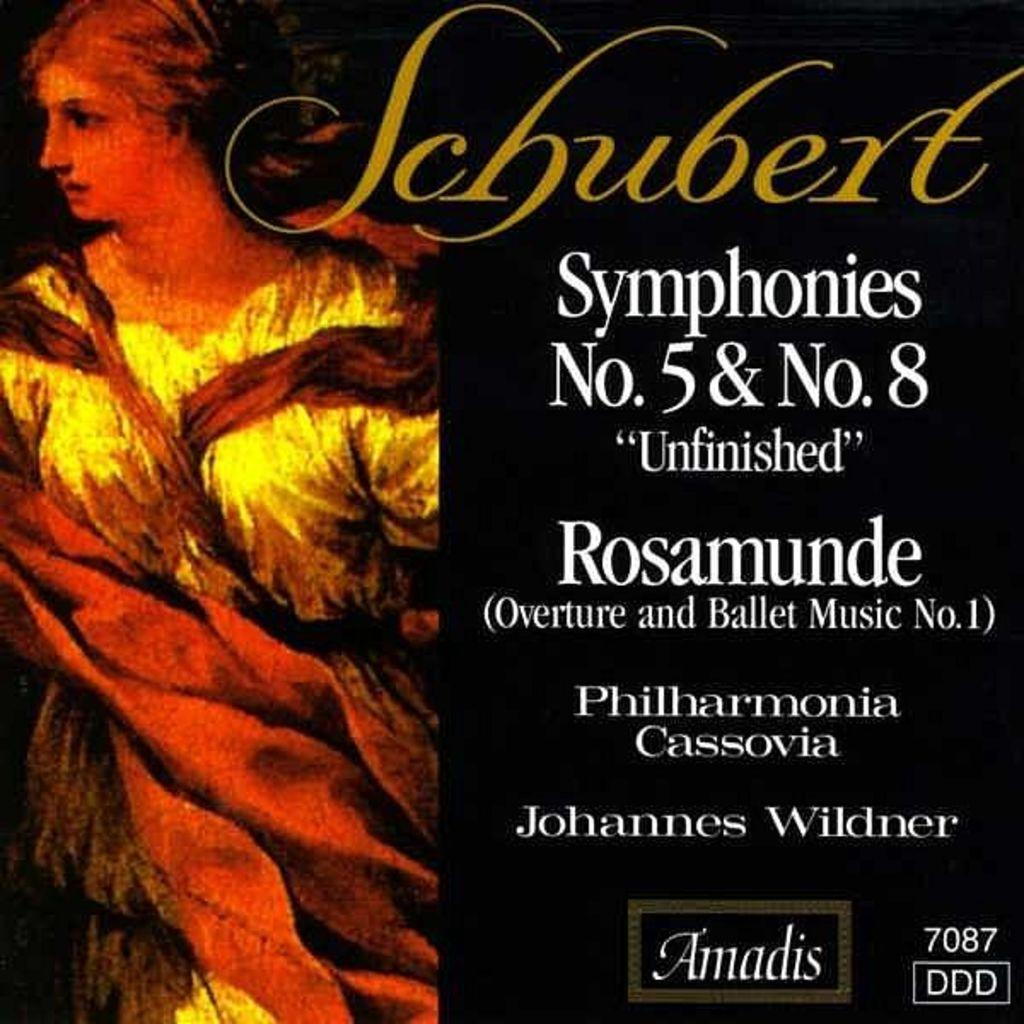<image>
Render a clear and concise summary of the photo. A record cover for Schubert's Symphonies Number 5 and 8. 